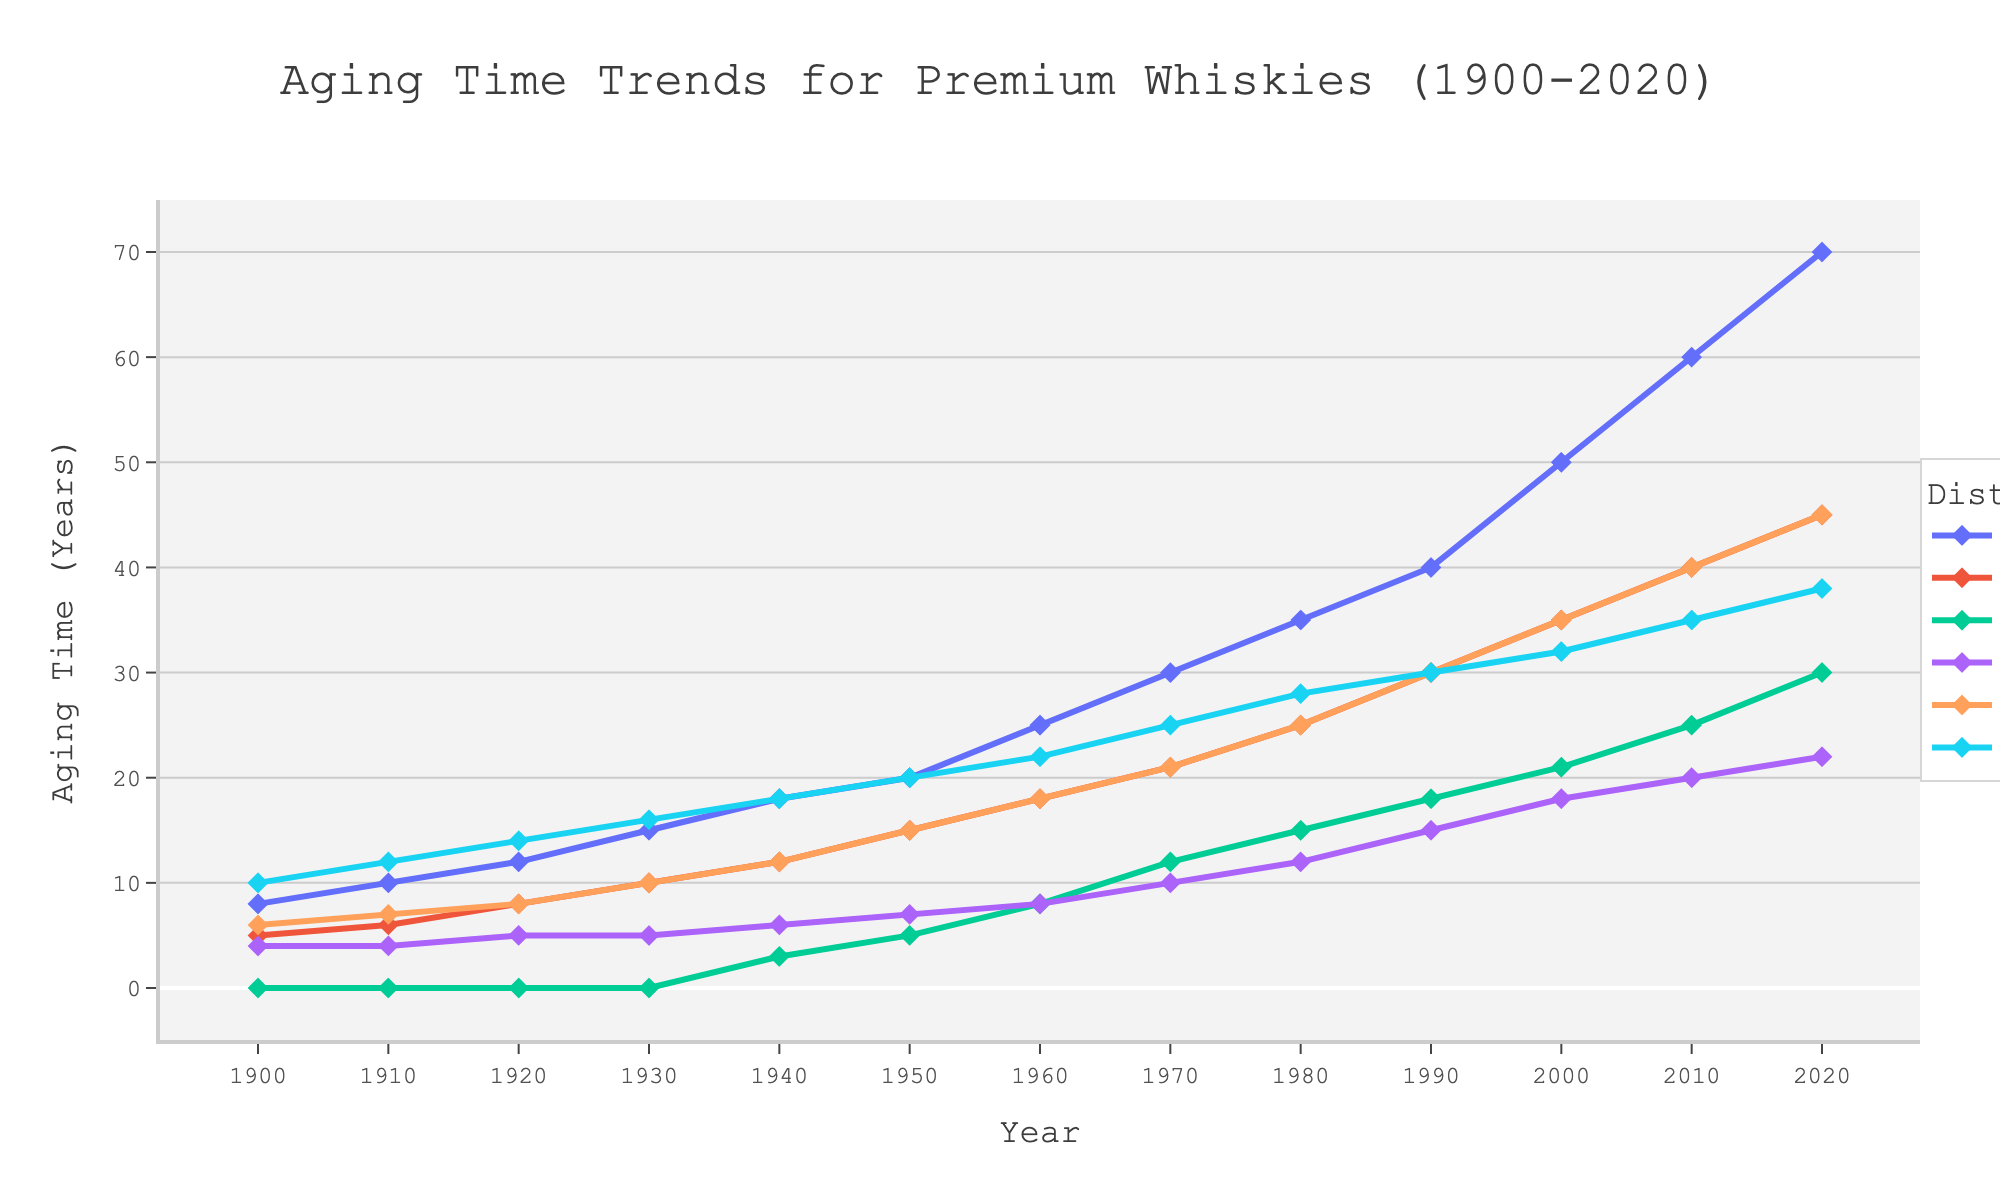Which distillery had the highest aging time in 2020? To find this, look at the data points for the year 2020 and identify the highest value. Macallan has the highest value at 70 years.
Answer: Macallan How did the aging time for Yamazaki change between 1940 and 1980? Look at the aging times for Yamazaki in 1940 and 1980: 3 years in 1940 increased to 15 years in 1980. Subtract 3 from 15 to find the difference.
Answer: Increased by 12 years Which distillery showed the highest increase in aging time from 1900 to 2020? Calculate the increase for each distillery from 1900 to 2020. Macallan increased from 8 to 70 years (62 years), Glenfiddich from 5 to 45 years (40 years), Yamazaki from 0 to 30 years (30 years), Jack Daniel's from 4 to 22 years (18 years), Glenmorangie from 6 to 45 years (39 years), and Lagavulin from 10 to 38 years (28 years). Macallan shows the highest increase of 62 years.
Answer: Macallan Which two distilleries had equal aging times in 1910 and what was that value? Look at the aging times for all distilleries in 1910. Both Jack Daniel's and Yamazaki have an aging time of 4 years in 1910.
Answer: Jack Daniel's and Yamazaki, 4 years Between Glenmorangie and Lagavulin, which distillery had a larger increase in aging time from 1950 to 2000? Calculate the increase for Glenmorangie (from 15 to 35 years) which is 20 years, and for Lagavulin (from 20 to 32 years) which is 12 years. Glenmorangie had a larger increase.
Answer: Glenmorangie In which decade did Yamazaki first appear on the chart? Locate the first non-zero value for Yamazaki; the value first appears in 1940.
Answer: 1940 What is the difference in aging time between Glenfiddich and Glenmorangie in the year 2000? In 2000, Glenfiddich’s aging time is 35 years while Glenmorangie’s is also 35 years. Subtracting these gives 0.
Answer: 0 years Which distillery experienced the most significant increase in aging time between 1970 and 1980? Calculate the increase for each distillery: Macallan (from 30 to 35 years, 5 years), Glenfiddich (21 to 25 years, 4 years), Yamazaki (12 to 15 years, 3 years), Jack Daniel's (10 to 12 years, 2 years), Glenmorangie (21 to 25 years, 4 years), Lagavulin (25 to 28 years, 3 years). Macallan had the most significant increase of 5 years.
Answer: Macallan How does the aging time in 2010 compare between Glenfiddich and Lagavulin? In 2010, Glenfiddich has an aging time of 40 years, while Lagavulin has 35 years. Comparing these, Glenfiddich has a higher aging time than Lagavulin.
Answer: Glenfiddich What was the average aging time for all distilleries in 1980? Sum the aging times across all distilleries in 1980: Macallan (35), Glenfiddich (25), Yamazaki (15), Jack Daniel's (12), Glenmorangie (25), Lagavulin (28). The total is 140. Divide this by the number of distilleries, which is 6.
Answer: 23.33 years 